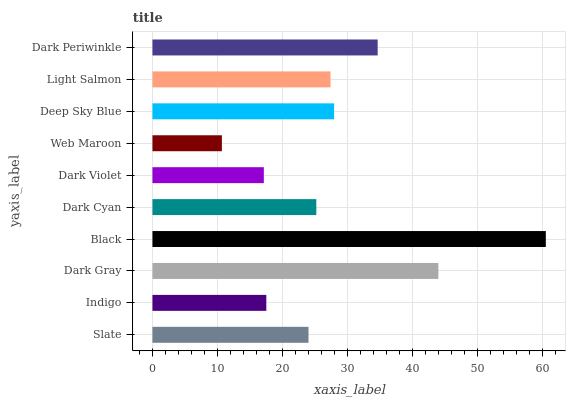Is Web Maroon the minimum?
Answer yes or no. Yes. Is Black the maximum?
Answer yes or no. Yes. Is Indigo the minimum?
Answer yes or no. No. Is Indigo the maximum?
Answer yes or no. No. Is Slate greater than Indigo?
Answer yes or no. Yes. Is Indigo less than Slate?
Answer yes or no. Yes. Is Indigo greater than Slate?
Answer yes or no. No. Is Slate less than Indigo?
Answer yes or no. No. Is Light Salmon the high median?
Answer yes or no. Yes. Is Dark Cyan the low median?
Answer yes or no. Yes. Is Dark Periwinkle the high median?
Answer yes or no. No. Is Web Maroon the low median?
Answer yes or no. No. 